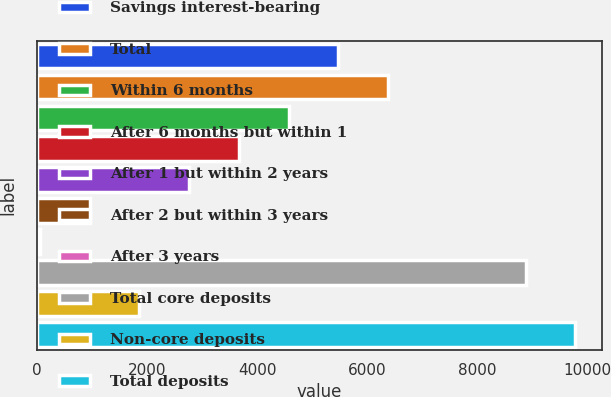Convert chart. <chart><loc_0><loc_0><loc_500><loc_500><bar_chart><fcel>Savings interest-bearing<fcel>Total<fcel>Within 6 months<fcel>After 6 months but within 1<fcel>After 1 but within 2 years<fcel>After 2 but within 3 years<fcel>After 3 years<fcel>Total core deposits<fcel>Non-core deposits<fcel>Total deposits<nl><fcel>5474.12<fcel>6376.24<fcel>4572<fcel>3669.88<fcel>2767.76<fcel>963.52<fcel>61.4<fcel>8872.7<fcel>1865.64<fcel>9774.82<nl></chart> 